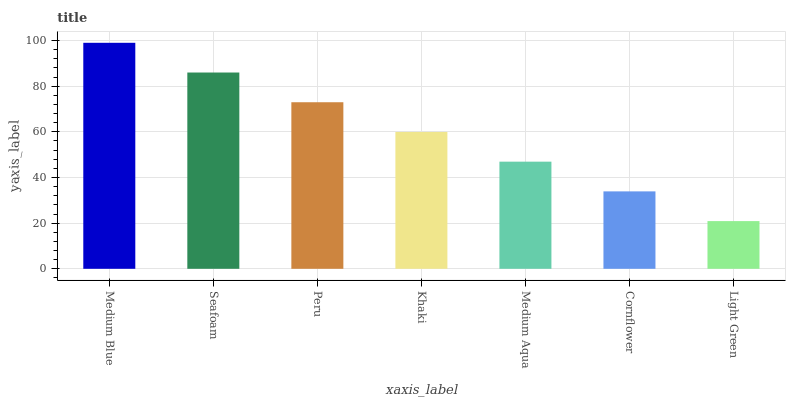Is Light Green the minimum?
Answer yes or no. Yes. Is Medium Blue the maximum?
Answer yes or no. Yes. Is Seafoam the minimum?
Answer yes or no. No. Is Seafoam the maximum?
Answer yes or no. No. Is Medium Blue greater than Seafoam?
Answer yes or no. Yes. Is Seafoam less than Medium Blue?
Answer yes or no. Yes. Is Seafoam greater than Medium Blue?
Answer yes or no. No. Is Medium Blue less than Seafoam?
Answer yes or no. No. Is Khaki the high median?
Answer yes or no. Yes. Is Khaki the low median?
Answer yes or no. Yes. Is Medium Aqua the high median?
Answer yes or no. No. Is Seafoam the low median?
Answer yes or no. No. 